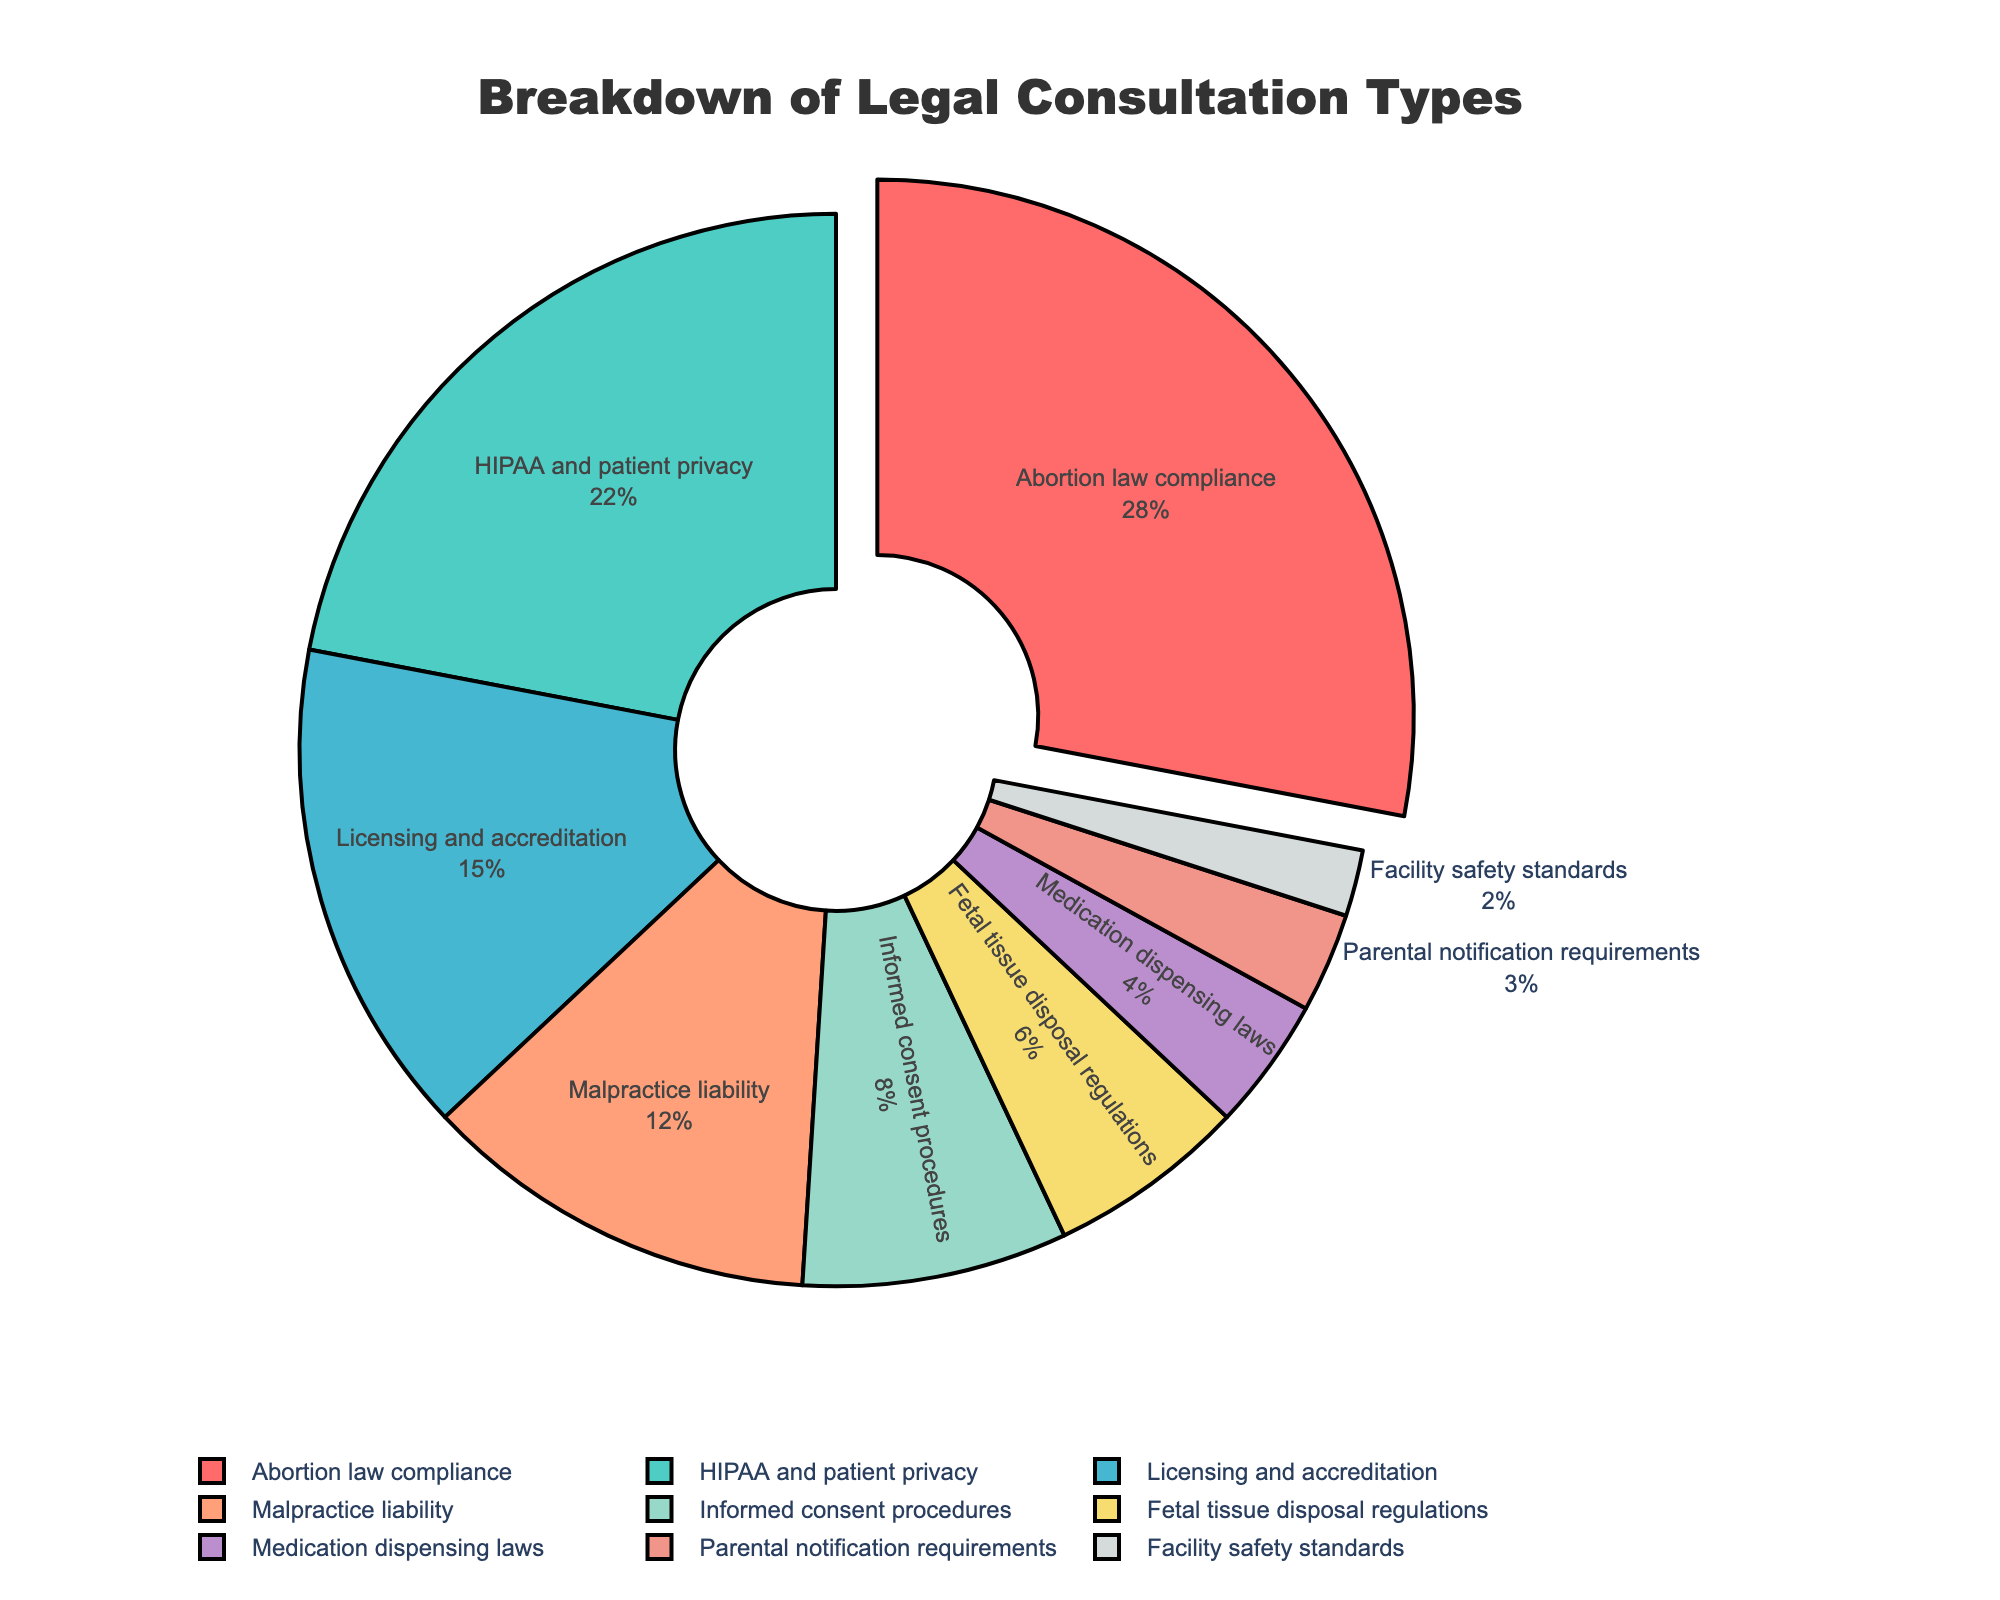What percentage of legal consultations is attributed to HIPAA and patient privacy? The pie chart shows the percentage next to the label "HIPAA and patient privacy," which is 22%.
Answer: 22% How does the percentage of legal consultations about abortion law compliance compare to those about malpractice liability? The pie chart shows that abortion law compliance accounts for 28% of consultations, while malpractice liability is 12%. By comparing these numbers, we see that abortion law compliance has a higher percentage.
Answer: Abortion law compliance is higher What is the combined percentage of legal consultations for licensing and accreditation, and informed consent procedures? The pie chart indicates 15% for licensing and accreditation, and 8% for informed consent procedures. Adding these two percentages together, 15 + 8 equals 23%.
Answer: 23% Which consultation type is the least sought after according to the pie chart? By observing the pie chart, the label "Facility safety standards" has the smallest section, corresponding to 2%.
Answer: Facility safety standards How does the percentage of consultations for parental notification requirements compare to that for medication dispensing laws? The pie chart shows 3% for parental notification requirements and 4% for medication dispensing laws. Comparing these values, medication dispensing laws have a higher percentage.
Answer: Medication dispensing laws are higher What visually differentiates the section of the pie chart corresponding to abortion law compliance from the other sections? In the pie chart, the section for "Abortion law compliance" is pulled out slightly (offset) from the rest of the chart, making it visually distinct.
Answer: It is pulled out slightly If you combine the percentages of consultations for fetal tissue disposal regulations and parental notification requirements, is their total less than those for HIPAA and patient privacy? The percentages for fetal tissue disposal regulations and parental notification requirements are 6% and 3%, respectively. Adding these together: 6 + 3 = 9%. Comparing this with HIPAA and patient privacy's 22%, 9% is indeed less than 22%.
Answer: Yes What percentage of consultations are devoted to topics other than abortion law compliance and HIPAA and patient privacy? First, calculate the combined percentage of abortion law compliance and HIPAA and patient privacy: 28 + 22 = 50%. Subtract this from 100% to find the percentage for other topics: 100 - 50 = 50%.
Answer: 50% Is the percentage of consultations for malpractice liability greater than the combined percentages of facility safety standards and parental notification requirements? The chart shows 12% for malpractice liability, and the combined percentages for facility safety standards and parental notification requirements are 2% + 3% = 5%. Since 12% is greater than 5%, the answer is yes.
Answer: Yes What's the total percentage of legal consultations related to regulatory compliance (sum of licensing and accreditation, fetal tissue disposal regulations, and facility safety standards)? The chart indicates the percentages as follows: licensing and accreditation (15%), fetal tissue disposal regulations (6%), and facility safety standards (2%). Adding these: 15 + 6 + 2 = 23%.
Answer: 23% 